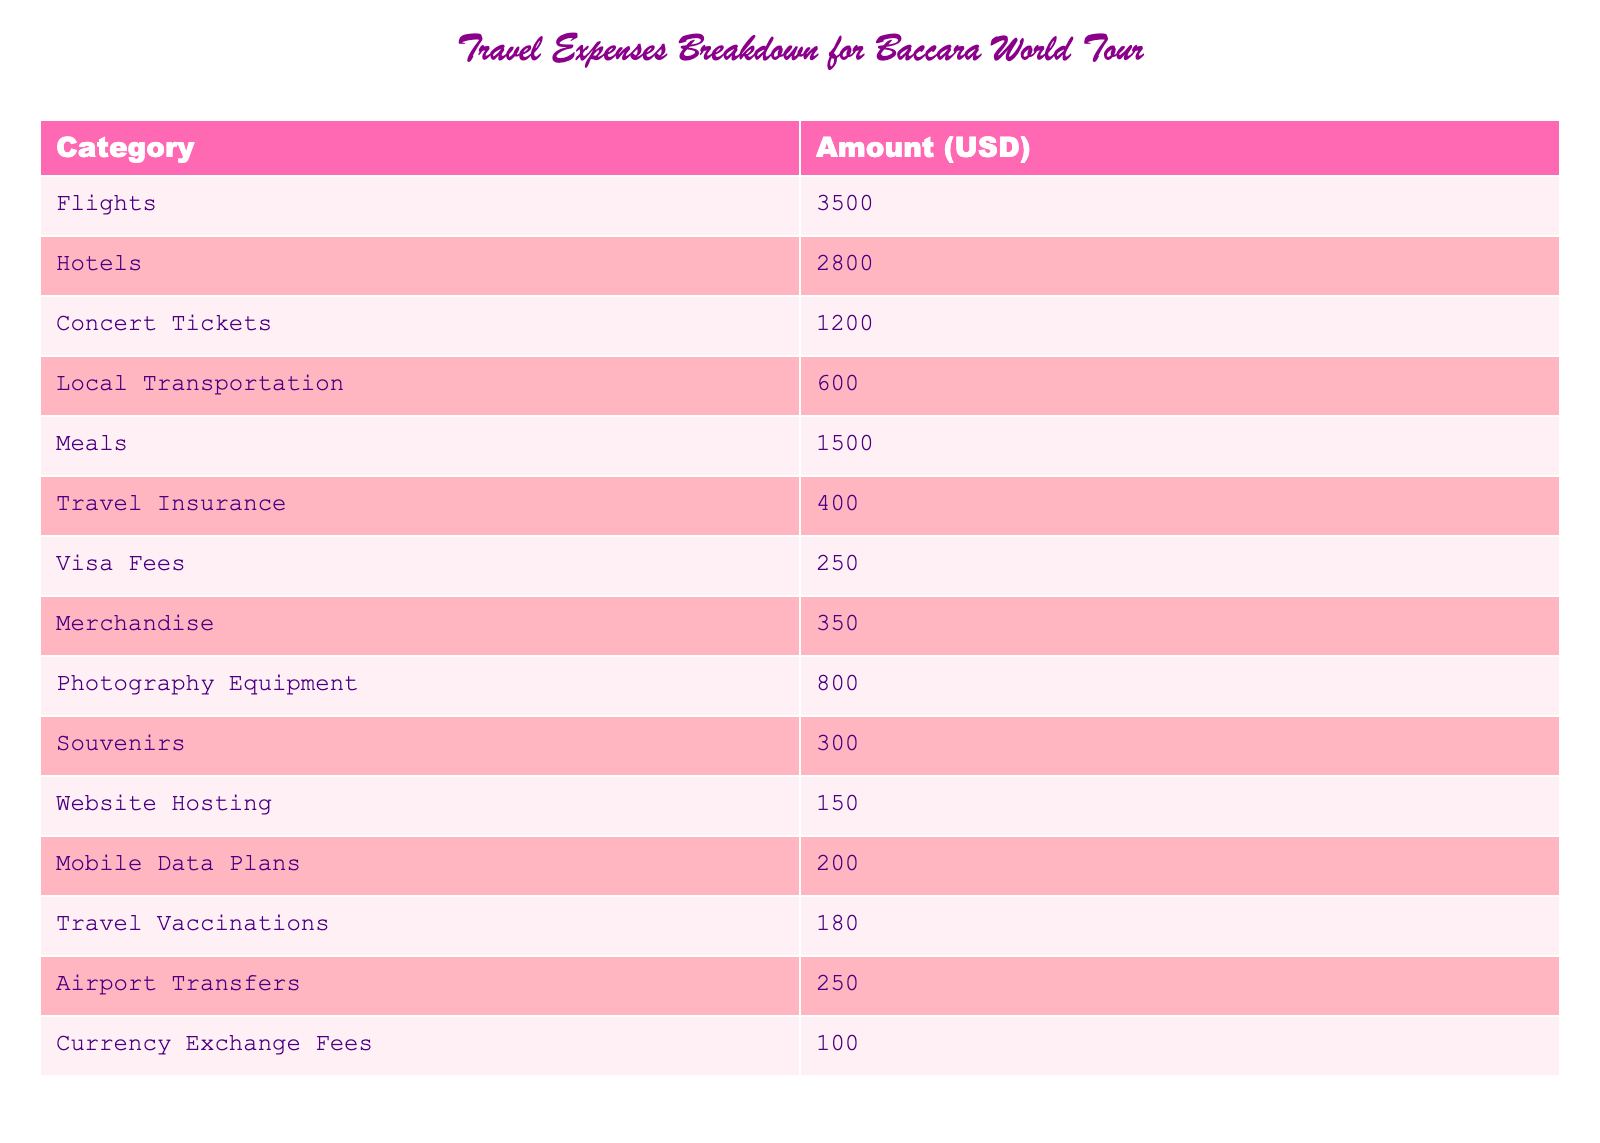What is the total amount spent on flights? The table indicates that the amount spent on flights is listed directly under the "Flights" category, which is $3500.
Answer: 3500 Which category has the highest expense? By comparing all the amounts listed in the table, the highest value is found under "Flights" at $3500.
Answer: Flights What is the total amount spent on food-related expenses? The food-related expense consists of "Meals" and is listed as $1500. There are no other food-related expenses in the table, hence the total is $1500.
Answer: 1500 How much more is spent on hotels than on concert tickets? The hotel expense is $2800 and concert tickets are $1200. The difference is calculated as $2800 - $1200 = $1600.
Answer: 1600 Is the amount spent on travel insurance more than the amount spent on visa fees? The expenditure on travel insurance is $400 and on visa fees is $250. Since $400 is greater than $250, the statement is true.
Answer: Yes What is the combined total for local transportation and airport transfers? Local transportation costs $600 and airport transfers are $250. The total is calculated by adding these two amounts: $600 + $250 = $850.
Answer: 850 Is the total spent on merchandise and souvenirs equal to $650? Merchandise expenses amount to $350 and souvenirs cost $300, so the total is $350 + $300 = $650, making the statement true.
Answer: Yes If we exclude travel insurance and visa fees, what is the remaining total of expenses? The total expense without insurance and visa fees is the sum of all other categories: $3500 (Flights) + $2800 (Hotels) + $1200 (Concert Tickets) + $600 (Local Transportation) + $1500 (Meals) + $350 (Merchandise) + $800 (Photography Equipment) + $300 (Souvenirs) + $150 (Website Hosting) + $200 (Mobile Data Plans) + $180 (Travel Vaccinations) + $250 (Airport Transfers) + $100 (Currency Exchange Fees) = $15780.
Answer: 15780 What percentage of the total expenses is represented by photography equipment? First, calculate the total expenses: $3500 + $2800 + $1200 + $600 + $1500 + $400 + $250 + $350 + $800 + $300 + $150 + $200 + $180 + $250 + $100 = $16780. Then, the percentage for photography equipment ($800) is calculated by ($800 / $16780) * 100, which is approximately 4.77%.
Answer: 4.77% 